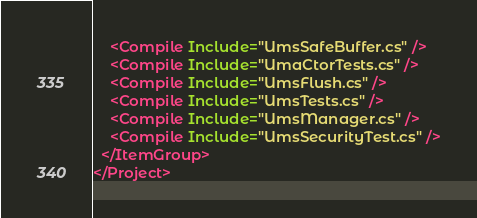Convert code to text. <code><loc_0><loc_0><loc_500><loc_500><_XML_>    <Compile Include="UmsSafeBuffer.cs" />
    <Compile Include="UmaCtorTests.cs" />
    <Compile Include="UmsFlush.cs" />
    <Compile Include="UmsTests.cs" />
    <Compile Include="UmsManager.cs" />
    <Compile Include="UmsSecurityTest.cs" />
  </ItemGroup>
</Project></code> 